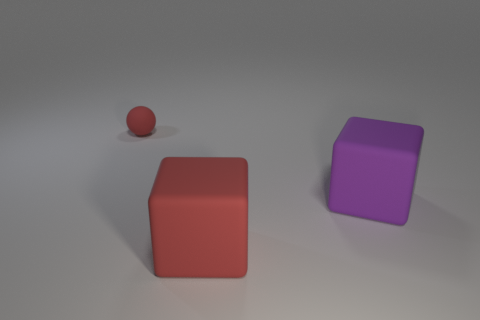Subtract all purple blocks. How many blocks are left? 1 Add 3 brown metal things. How many objects exist? 6 Subtract all balls. How many objects are left? 2 Subtract all big cubes. Subtract all small red rubber balls. How many objects are left? 0 Add 2 large purple things. How many large purple things are left? 3 Add 1 big red things. How many big red things exist? 2 Subtract 0 purple balls. How many objects are left? 3 Subtract all green balls. Subtract all brown cylinders. How many balls are left? 1 Subtract all green balls. How many red cubes are left? 1 